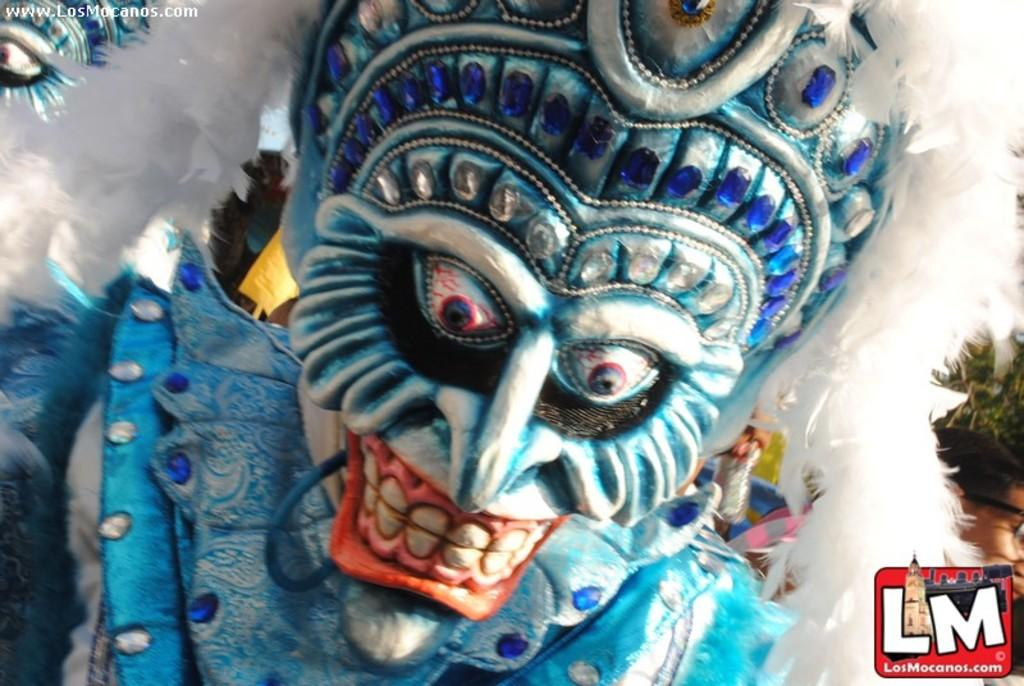What is the main subject of the image? There is a depiction in the middle of the image. Is there any text or symbol in the image? Yes, there is a logo in the bottom right corner of the image. How many goldfish are swimming in the image? There are no goldfish present in the image. What direction is the chair facing in the image? There is no chair present in the image. 